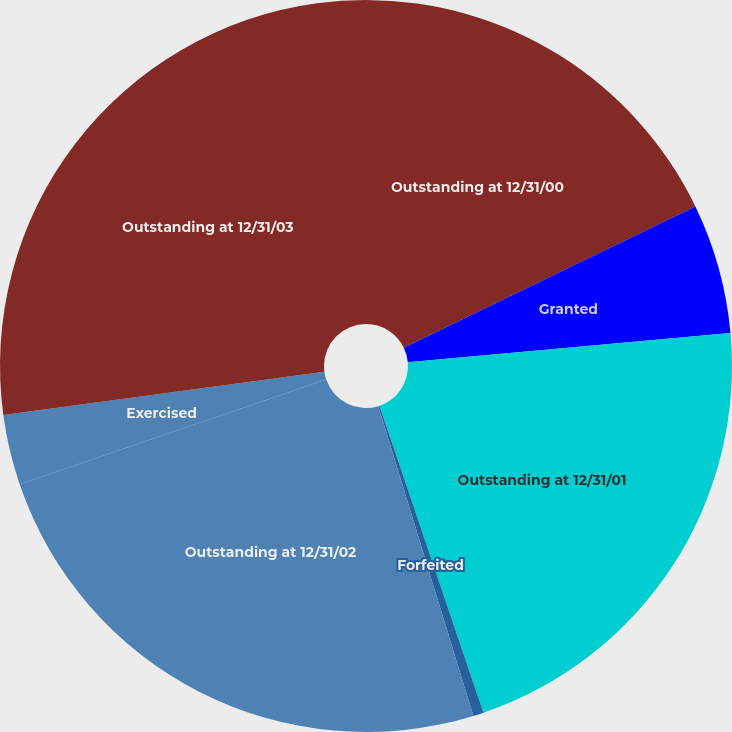Convert chart. <chart><loc_0><loc_0><loc_500><loc_500><pie_chart><fcel>Outstanding at 12/31/00<fcel>Granted<fcel>Outstanding at 12/31/01<fcel>Forfeited<fcel>Outstanding at 12/31/02<fcel>Exercised<fcel>Outstanding at 12/31/03<nl><fcel>17.82%<fcel>5.74%<fcel>21.24%<fcel>0.46%<fcel>24.5%<fcel>3.1%<fcel>27.14%<nl></chart> 